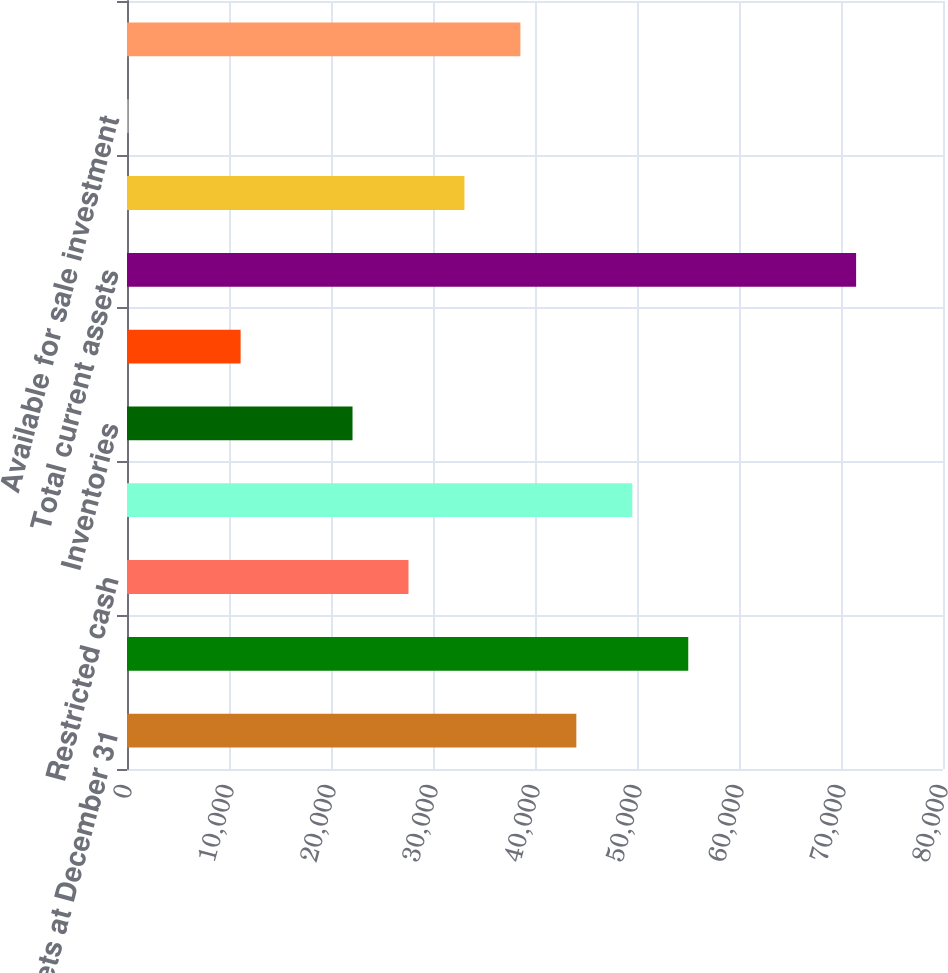Convert chart to OTSL. <chart><loc_0><loc_0><loc_500><loc_500><bar_chart><fcel>Assets at December 31<fcel>Cash and cash equivalents<fcel>Restricted cash<fcel>Trade receivables net of<fcel>Inventories<fcel>Other current assets<fcel>Total current assets<fcel>Investment in unconsolidated<fcel>Available for sale investment<fcel>Total investments<nl><fcel>44053.4<fcel>55025<fcel>27596<fcel>49539.2<fcel>22110.2<fcel>11138.6<fcel>71482.4<fcel>33081.8<fcel>167<fcel>38567.6<nl></chart> 